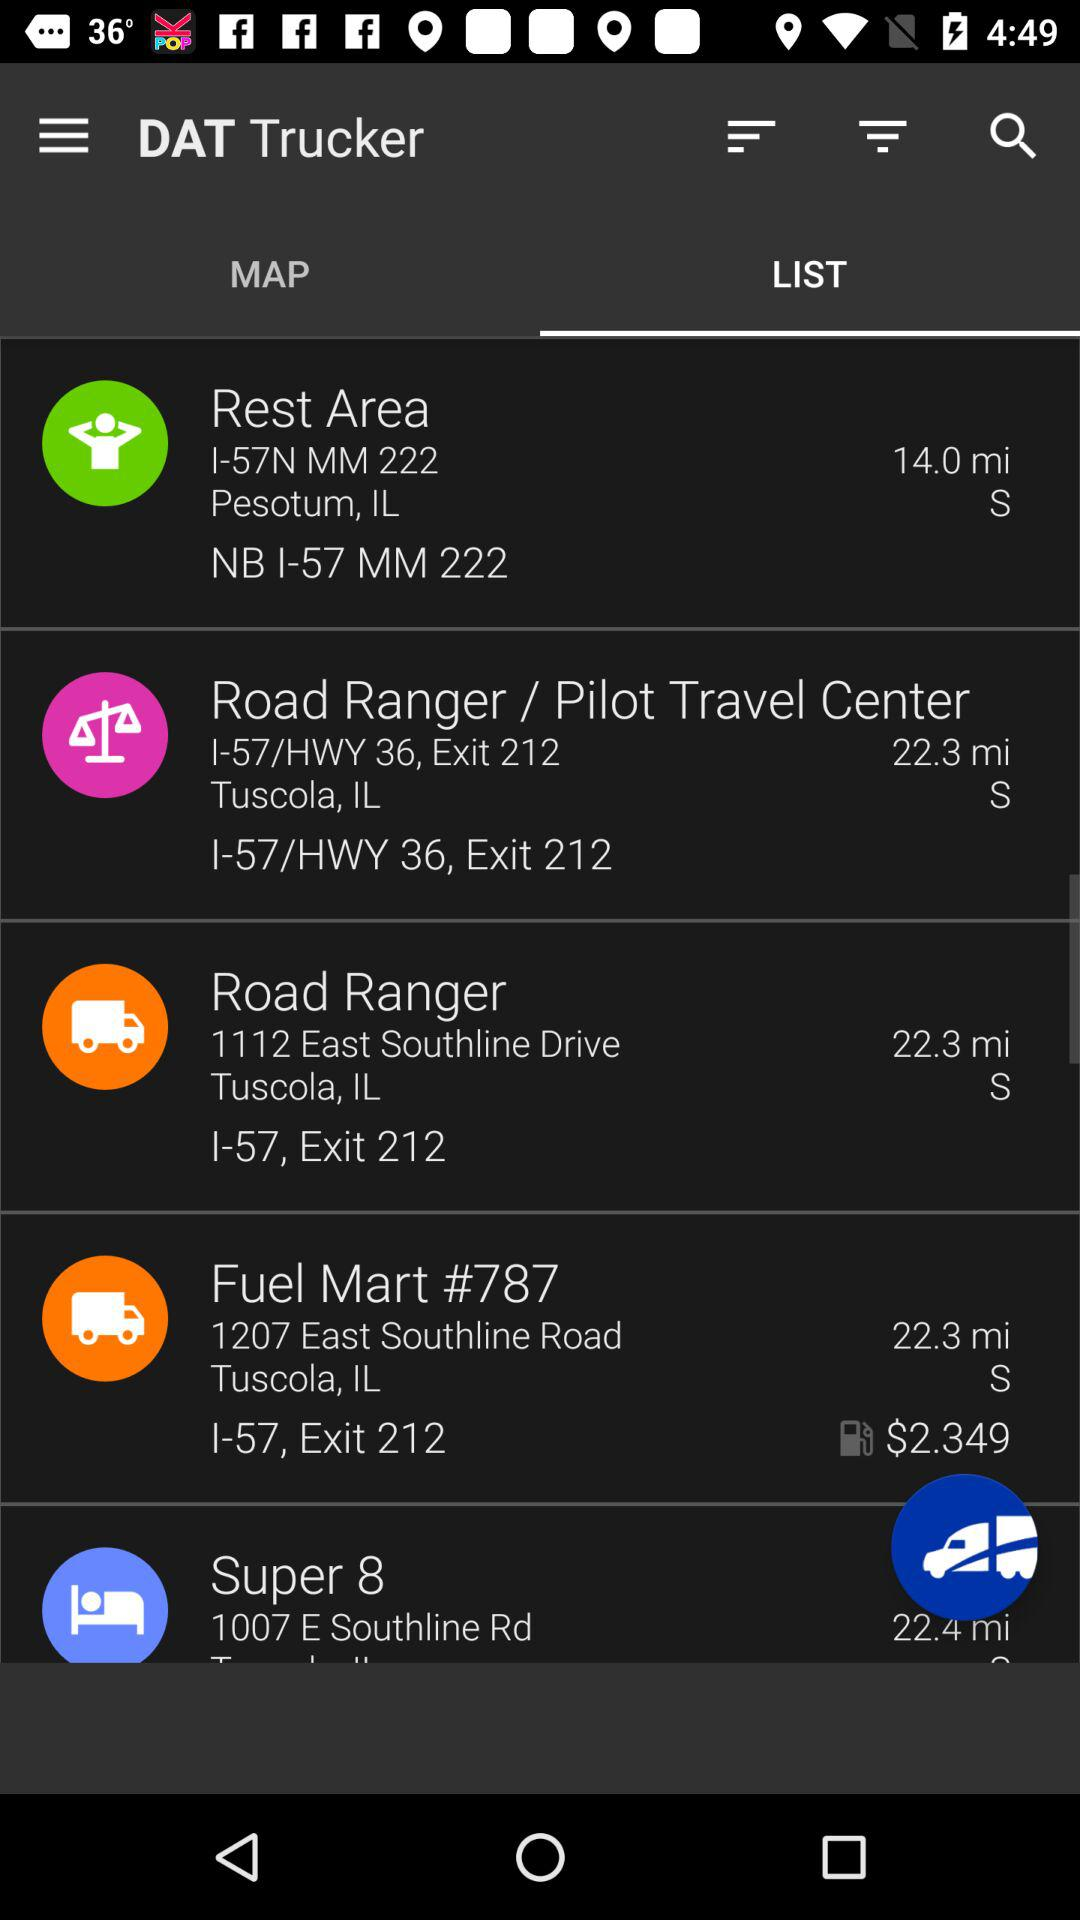What is the distance from "Road Ranger"? The distance is 22.3 miles. 